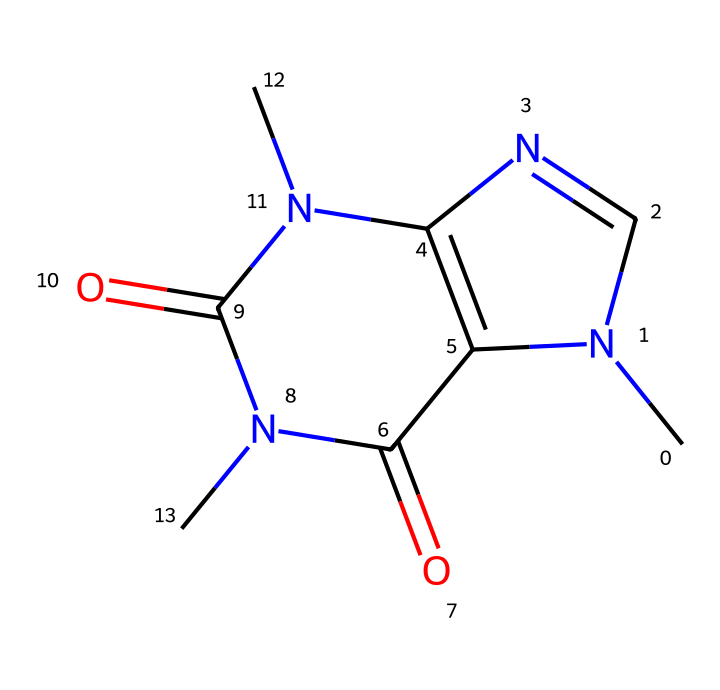What is the IUPAC name of this chemical? The SMILES representation indicates that this chemical has imide functional groups and nitrogen atoms in a fused ring system. The structure conforms to the name "1,3,7-Trimethylxanthine," which is the IUPAC name for caffeine.
Answer: 1,3,7-Trimethylxanthine How many nitrogen atoms are present in the structure? Analyzing the SMILES representation reveals that there are three nitrogen atoms present in the structure, denoted by the letter "N."
Answer: 3 What is the number of carbon atoms in this molecule? By examining the SMILES code, we count the carbon atoms represented in the structure, which totals to 8 carbon atoms.
Answer: 8 What kind of chemical functional groups are present in caffeine? Caffeine contains imide functional groups, as indicated by the "C(=O)N" structures in the SMILES representation, which are characteristic of imides.
Answer: imides What type of bonding is primarily present in caffeine? The structure indicates a mixture of single and double bonds, common in organic molecules. The presence of double bonds involving carbon and oxygen is a defining characteristic of its structure.
Answer: covalent What role does the imide group play in caffeine? The imide group contributes to the stability and solubility of caffeine, which affects its physiological activity as a stimulant. This is crucial for binding interactions with receptors in biological systems.
Answer: stability and solubility What makes caffeine a stimulant based on its chemical structure? The methyl groups attached to the nitrogen atoms enhance the potential for interaction with adenosine receptors, blocking their action, thus increasing alertness and reducing fatigue, classifying it as a stimulant.
Answer: enhances receptor interaction 